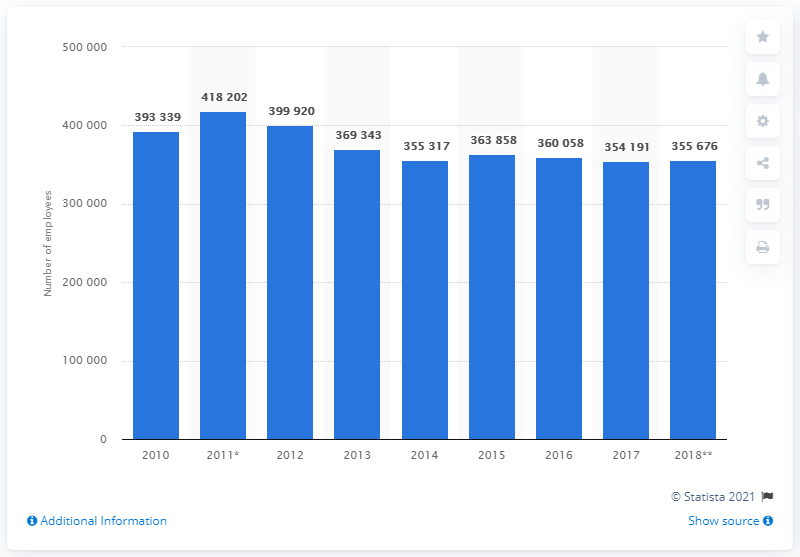List a handful of essential elements in this visual. In 2018, a total of 355,676 individuals were employed in the construction industry in Romania. 